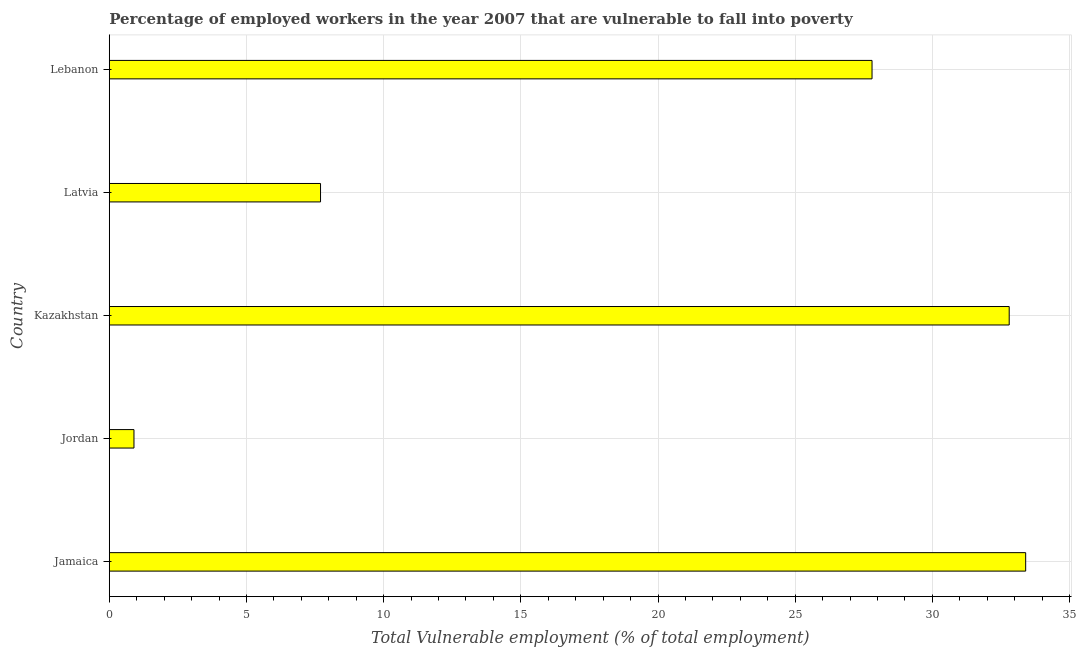What is the title of the graph?
Your response must be concise. Percentage of employed workers in the year 2007 that are vulnerable to fall into poverty. What is the label or title of the X-axis?
Keep it short and to the point. Total Vulnerable employment (% of total employment). What is the total vulnerable employment in Kazakhstan?
Provide a short and direct response. 32.8. Across all countries, what is the maximum total vulnerable employment?
Provide a short and direct response. 33.4. Across all countries, what is the minimum total vulnerable employment?
Provide a succinct answer. 0.9. In which country was the total vulnerable employment maximum?
Provide a short and direct response. Jamaica. In which country was the total vulnerable employment minimum?
Your response must be concise. Jordan. What is the sum of the total vulnerable employment?
Give a very brief answer. 102.6. What is the difference between the total vulnerable employment in Latvia and Lebanon?
Provide a succinct answer. -20.1. What is the average total vulnerable employment per country?
Offer a very short reply. 20.52. What is the median total vulnerable employment?
Ensure brevity in your answer.  27.8. What is the ratio of the total vulnerable employment in Jamaica to that in Kazakhstan?
Ensure brevity in your answer.  1.02. What is the difference between the highest and the lowest total vulnerable employment?
Your answer should be very brief. 32.5. In how many countries, is the total vulnerable employment greater than the average total vulnerable employment taken over all countries?
Provide a short and direct response. 3. How many bars are there?
Make the answer very short. 5. Are all the bars in the graph horizontal?
Your response must be concise. Yes. What is the difference between two consecutive major ticks on the X-axis?
Provide a short and direct response. 5. What is the Total Vulnerable employment (% of total employment) in Jamaica?
Keep it short and to the point. 33.4. What is the Total Vulnerable employment (% of total employment) in Jordan?
Ensure brevity in your answer.  0.9. What is the Total Vulnerable employment (% of total employment) in Kazakhstan?
Provide a short and direct response. 32.8. What is the Total Vulnerable employment (% of total employment) of Latvia?
Your answer should be very brief. 7.7. What is the Total Vulnerable employment (% of total employment) in Lebanon?
Provide a succinct answer. 27.8. What is the difference between the Total Vulnerable employment (% of total employment) in Jamaica and Jordan?
Your answer should be compact. 32.5. What is the difference between the Total Vulnerable employment (% of total employment) in Jamaica and Kazakhstan?
Give a very brief answer. 0.6. What is the difference between the Total Vulnerable employment (% of total employment) in Jamaica and Latvia?
Offer a terse response. 25.7. What is the difference between the Total Vulnerable employment (% of total employment) in Jamaica and Lebanon?
Ensure brevity in your answer.  5.6. What is the difference between the Total Vulnerable employment (% of total employment) in Jordan and Kazakhstan?
Offer a very short reply. -31.9. What is the difference between the Total Vulnerable employment (% of total employment) in Jordan and Lebanon?
Keep it short and to the point. -26.9. What is the difference between the Total Vulnerable employment (% of total employment) in Kazakhstan and Latvia?
Provide a succinct answer. 25.1. What is the difference between the Total Vulnerable employment (% of total employment) in Latvia and Lebanon?
Give a very brief answer. -20.1. What is the ratio of the Total Vulnerable employment (% of total employment) in Jamaica to that in Jordan?
Make the answer very short. 37.11. What is the ratio of the Total Vulnerable employment (% of total employment) in Jamaica to that in Kazakhstan?
Your answer should be compact. 1.02. What is the ratio of the Total Vulnerable employment (% of total employment) in Jamaica to that in Latvia?
Offer a terse response. 4.34. What is the ratio of the Total Vulnerable employment (% of total employment) in Jamaica to that in Lebanon?
Give a very brief answer. 1.2. What is the ratio of the Total Vulnerable employment (% of total employment) in Jordan to that in Kazakhstan?
Your response must be concise. 0.03. What is the ratio of the Total Vulnerable employment (% of total employment) in Jordan to that in Latvia?
Your answer should be compact. 0.12. What is the ratio of the Total Vulnerable employment (% of total employment) in Jordan to that in Lebanon?
Offer a terse response. 0.03. What is the ratio of the Total Vulnerable employment (% of total employment) in Kazakhstan to that in Latvia?
Your answer should be very brief. 4.26. What is the ratio of the Total Vulnerable employment (% of total employment) in Kazakhstan to that in Lebanon?
Keep it short and to the point. 1.18. What is the ratio of the Total Vulnerable employment (% of total employment) in Latvia to that in Lebanon?
Make the answer very short. 0.28. 